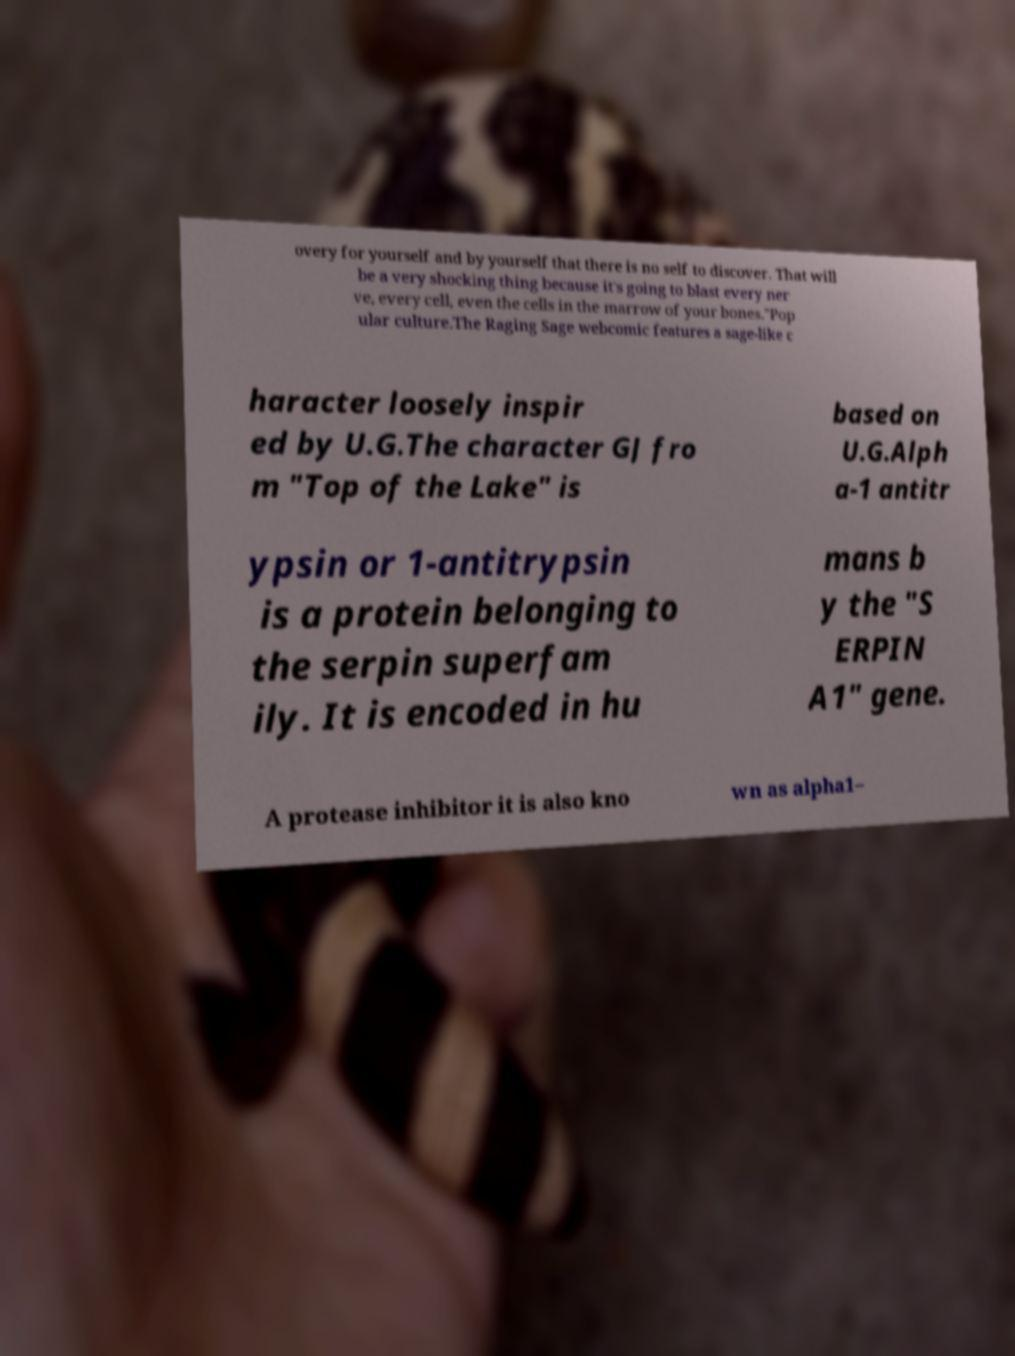Could you assist in decoding the text presented in this image and type it out clearly? overy for yourself and by yourself that there is no self to discover. That will be a very shocking thing because it's going to blast every ner ve, every cell, even the cells in the marrow of your bones."Pop ular culture.The Raging Sage webcomic features a sage-like c haracter loosely inspir ed by U.G.The character GJ fro m "Top of the Lake" is based on U.G.Alph a-1 antitr ypsin or 1-antitrypsin is a protein belonging to the serpin superfam ily. It is encoded in hu mans b y the "S ERPIN A1" gene. A protease inhibitor it is also kno wn as alpha1– 